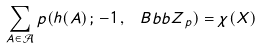<formula> <loc_0><loc_0><loc_500><loc_500>\sum _ { A \in \mathcal { A } } p ( h ( A ) \, ; \, - 1 \, , \, { \ B b b Z } _ { p } ) = \chi ( X )</formula> 